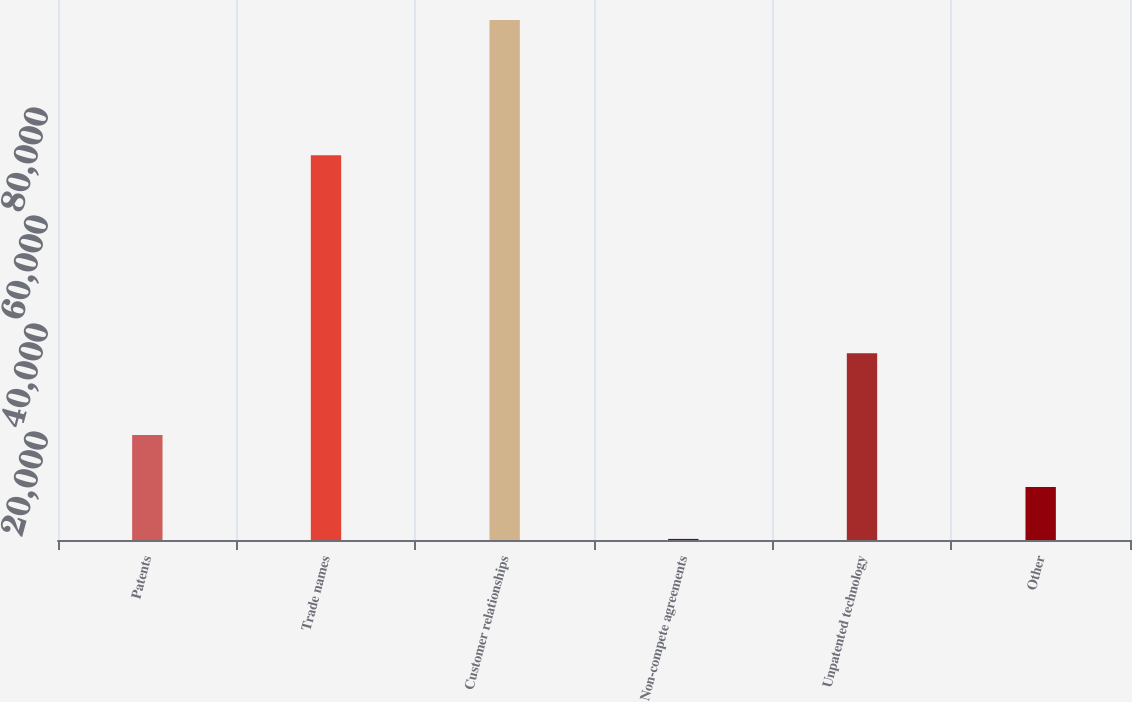Convert chart to OTSL. <chart><loc_0><loc_0><loc_500><loc_500><bar_chart><fcel>Patents<fcel>Trade names<fcel>Customer relationships<fcel>Non-compete agreements<fcel>Unpatented technology<fcel>Other<nl><fcel>19421.8<fcel>71237<fcel>96293<fcel>204<fcel>34595<fcel>9812.9<nl></chart> 